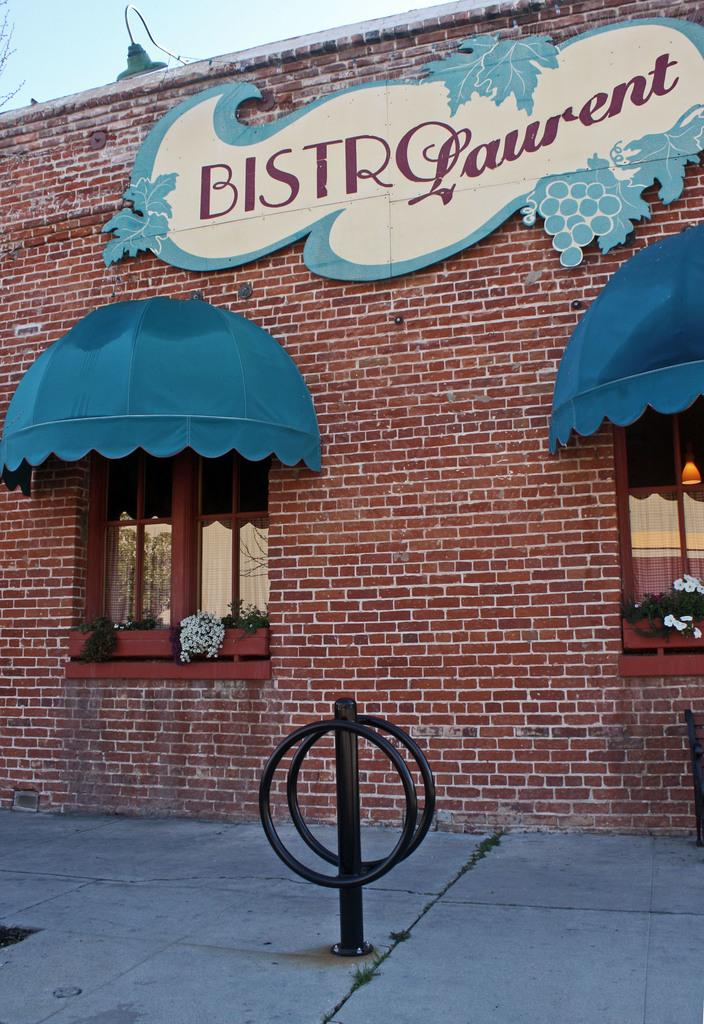What is the main structure in the image? There is a building in the image. What can be seen inside the building through a window? Plants are visible in a window in the image. What is visible in the background of the image? The sky is visible in the image. What type of cord is used to connect the seashore to the building in the image? There is no cord or seashore present in the image; it only features a building and plants in a window. 